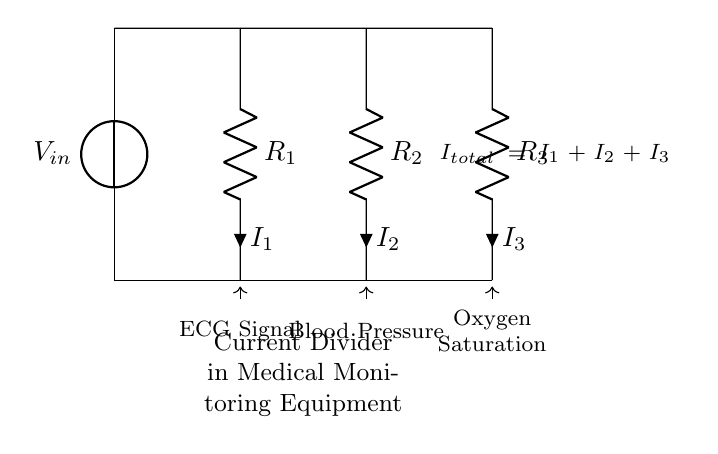What is the total current in the circuit? The total current is the sum of the currents through each resistor, represented as I total, which equals I 1 plus I 2 plus I 3.
Answer: I total What type of circuit is depicted in the diagram? The circuit shown is a current divider circuit, where the input current splits across multiple branches.
Answer: Current divider How many resistors are in the circuit? There are three resistors represented by R 1, R 2, and R 3 that the current divides through.
Answer: Three What is the function of the current divider in medical equipment? The current divider allows for the measurement of multiple vital signs like ECG, blood pressure, and oxygen saturation by distributing the current through different paths.
Answer: Measuring vital signs Which component measures ECG signals? The resistor R 1 is associated with the current that measures the ECG signals in the vital signs monitoring setup.
Answer: R 1 Which resistor is responsible for measuring blood pressure? The resistor R 2 is designated for the current flow that relates to blood pressure measurements in the monitoring equipment.
Answer: R 2 What happens if one resistor fails in a current divider circuit? If one resistor fails, the current division will be uneven, potentially affecting the readings of the connected medical equipment and leading to inaccurate vital sign measurements.
Answer: Uneven current division 